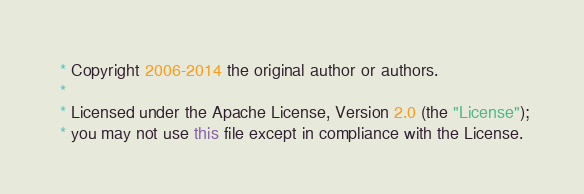<code> <loc_0><loc_0><loc_500><loc_500><_Java_> * Copyright 2006-2014 the original author or authors.
 *
 * Licensed under the Apache License, Version 2.0 (the "License");
 * you may not use this file except in compliance with the License.</code> 